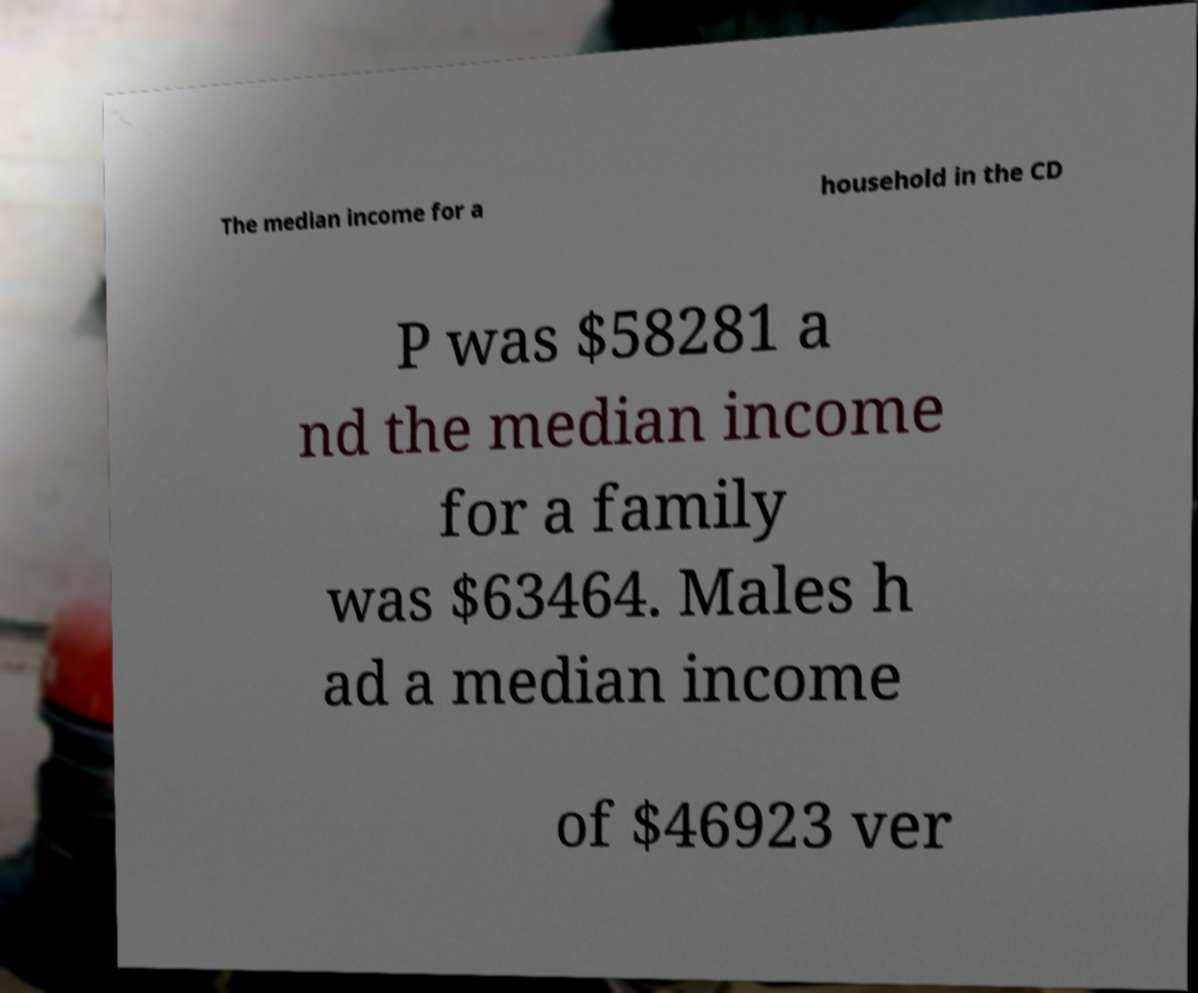For documentation purposes, I need the text within this image transcribed. Could you provide that? The median income for a household in the CD P was $58281 a nd the median income for a family was $63464. Males h ad a median income of $46923 ver 